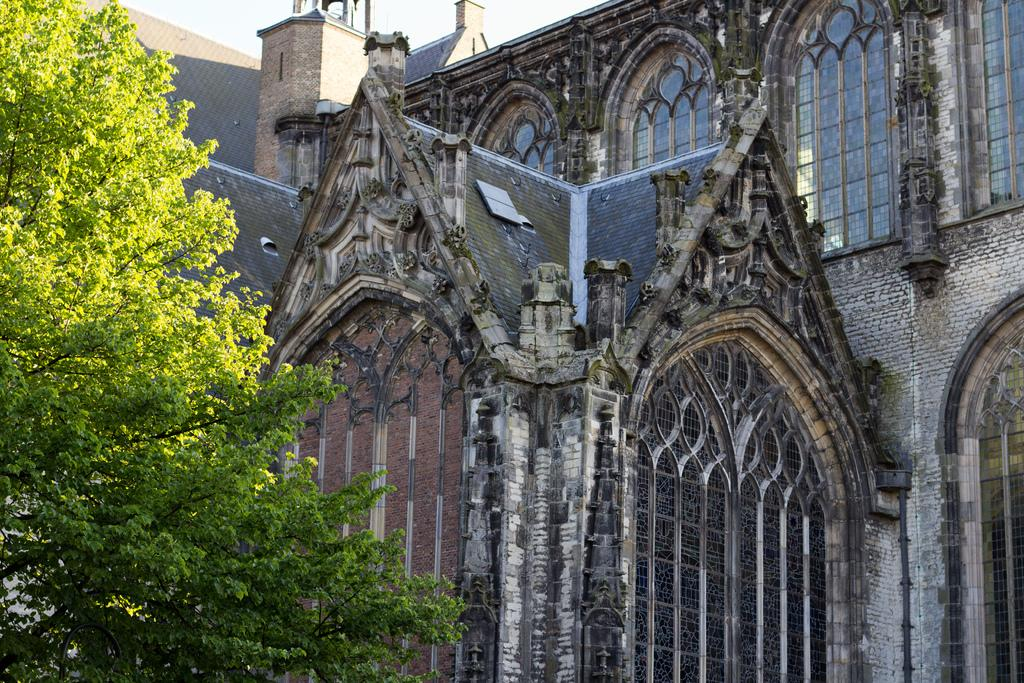What type of structures can be seen in the image? There are buildings in the image. What other natural elements are present in the image? There are trees in the image. How would you describe the sky in the image? The sky is cloudy in the image. What songs can be heard playing in the background of the image? There is no audio or sound present in the image, so it's not possible to determine what songs might be heard. Is there any motion or movement happening in the image? The image is a still photograph, so there is no motion or movement visible. 